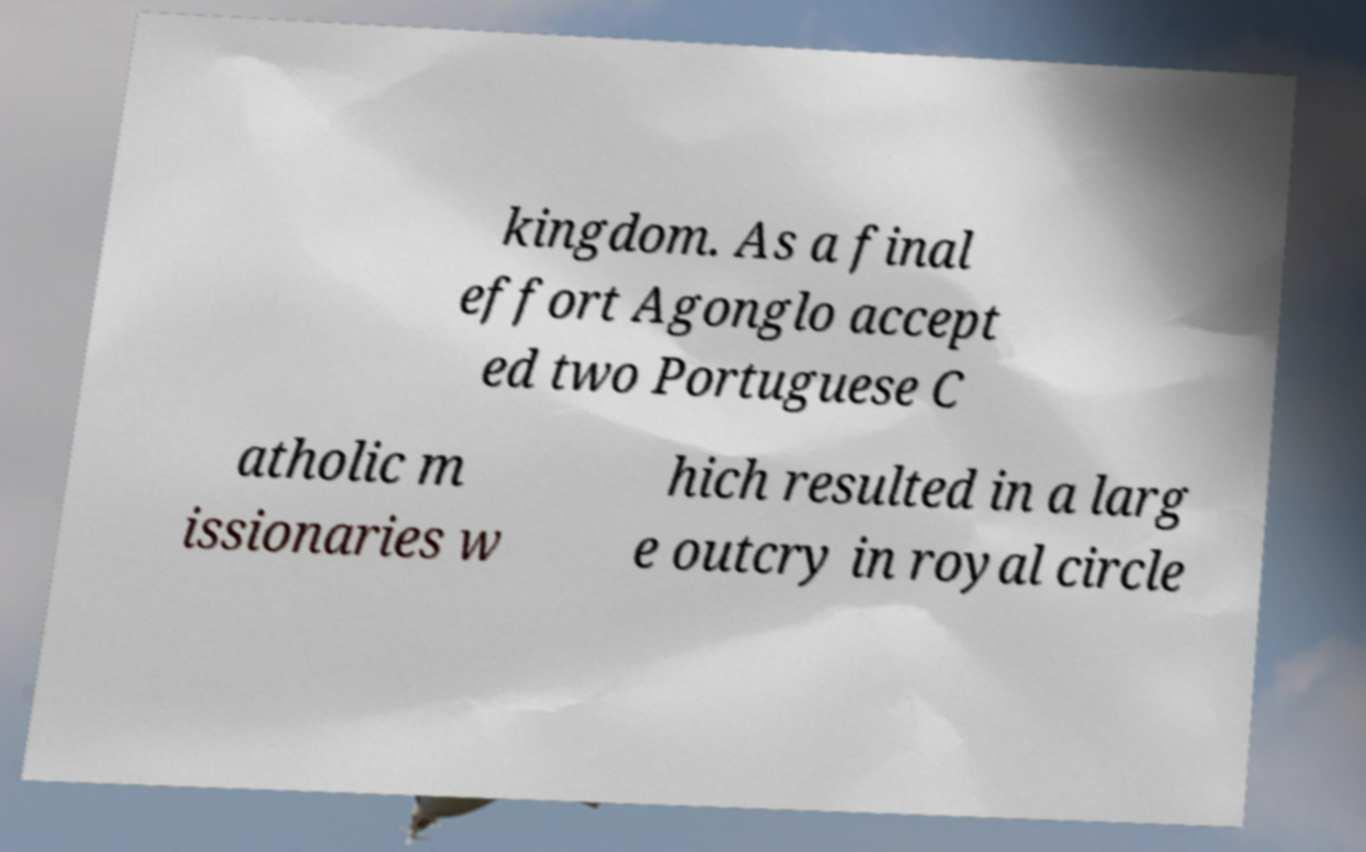Could you assist in decoding the text presented in this image and type it out clearly? kingdom. As a final effort Agonglo accept ed two Portuguese C atholic m issionaries w hich resulted in a larg e outcry in royal circle 